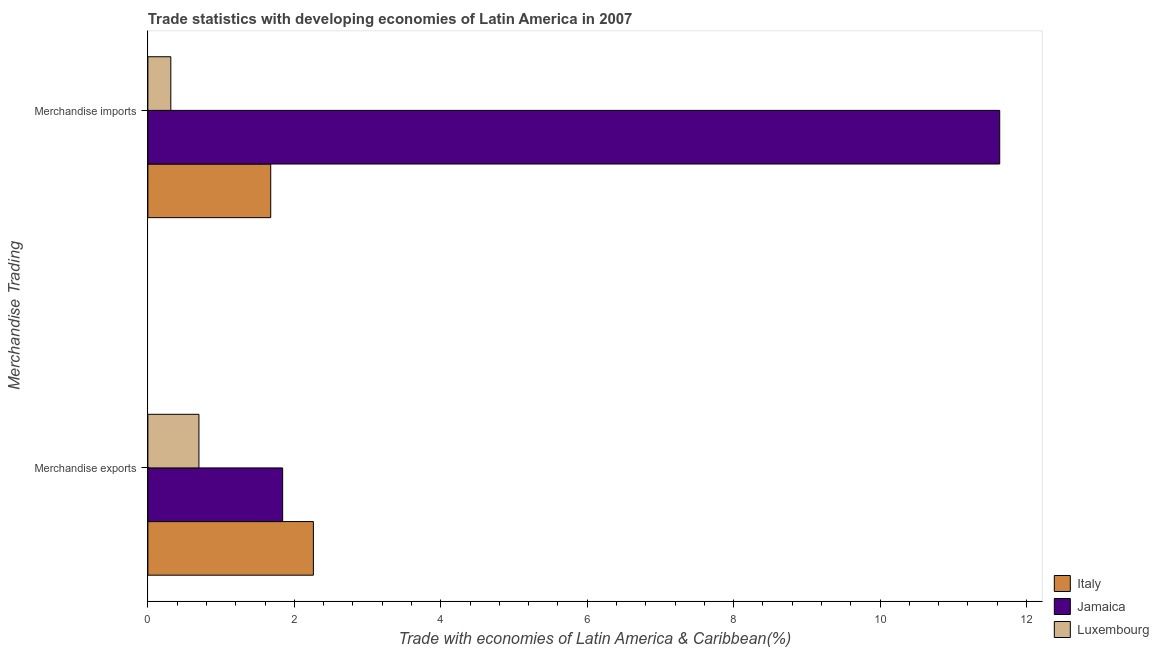How many groups of bars are there?
Make the answer very short. 2. Are the number of bars per tick equal to the number of legend labels?
Your answer should be compact. Yes. How many bars are there on the 2nd tick from the top?
Make the answer very short. 3. How many bars are there on the 2nd tick from the bottom?
Your answer should be very brief. 3. What is the merchandise exports in Italy?
Ensure brevity in your answer.  2.26. Across all countries, what is the maximum merchandise imports?
Your answer should be very brief. 11.63. Across all countries, what is the minimum merchandise exports?
Provide a succinct answer. 0.7. In which country was the merchandise imports maximum?
Make the answer very short. Jamaica. In which country was the merchandise exports minimum?
Your answer should be very brief. Luxembourg. What is the total merchandise exports in the graph?
Keep it short and to the point. 4.8. What is the difference between the merchandise imports in Italy and that in Jamaica?
Your response must be concise. -9.96. What is the difference between the merchandise imports in Jamaica and the merchandise exports in Italy?
Offer a terse response. 9.37. What is the average merchandise imports per country?
Your answer should be compact. 4.54. What is the difference between the merchandise exports and merchandise imports in Luxembourg?
Offer a very short reply. 0.38. What is the ratio of the merchandise imports in Luxembourg to that in Jamaica?
Your answer should be compact. 0.03. What does the 3rd bar from the top in Merchandise exports represents?
Give a very brief answer. Italy. What does the 3rd bar from the bottom in Merchandise exports represents?
Provide a short and direct response. Luxembourg. How many bars are there?
Keep it short and to the point. 6. Are all the bars in the graph horizontal?
Your response must be concise. Yes. How many countries are there in the graph?
Ensure brevity in your answer.  3. Where does the legend appear in the graph?
Provide a succinct answer. Bottom right. What is the title of the graph?
Provide a succinct answer. Trade statistics with developing economies of Latin America in 2007. Does "Euro area" appear as one of the legend labels in the graph?
Your answer should be compact. No. What is the label or title of the X-axis?
Your answer should be compact. Trade with economies of Latin America & Caribbean(%). What is the label or title of the Y-axis?
Your response must be concise. Merchandise Trading. What is the Trade with economies of Latin America & Caribbean(%) in Italy in Merchandise exports?
Make the answer very short. 2.26. What is the Trade with economies of Latin America & Caribbean(%) of Jamaica in Merchandise exports?
Offer a terse response. 1.84. What is the Trade with economies of Latin America & Caribbean(%) of Luxembourg in Merchandise exports?
Provide a succinct answer. 0.7. What is the Trade with economies of Latin America & Caribbean(%) in Italy in Merchandise imports?
Provide a succinct answer. 1.68. What is the Trade with economies of Latin America & Caribbean(%) of Jamaica in Merchandise imports?
Offer a terse response. 11.63. What is the Trade with economies of Latin America & Caribbean(%) in Luxembourg in Merchandise imports?
Your answer should be very brief. 0.31. Across all Merchandise Trading, what is the maximum Trade with economies of Latin America & Caribbean(%) in Italy?
Provide a succinct answer. 2.26. Across all Merchandise Trading, what is the maximum Trade with economies of Latin America & Caribbean(%) in Jamaica?
Your answer should be very brief. 11.63. Across all Merchandise Trading, what is the maximum Trade with economies of Latin America & Caribbean(%) in Luxembourg?
Provide a short and direct response. 0.7. Across all Merchandise Trading, what is the minimum Trade with economies of Latin America & Caribbean(%) in Italy?
Offer a terse response. 1.68. Across all Merchandise Trading, what is the minimum Trade with economies of Latin America & Caribbean(%) of Jamaica?
Your answer should be very brief. 1.84. Across all Merchandise Trading, what is the minimum Trade with economies of Latin America & Caribbean(%) of Luxembourg?
Your answer should be compact. 0.31. What is the total Trade with economies of Latin America & Caribbean(%) in Italy in the graph?
Your answer should be compact. 3.94. What is the total Trade with economies of Latin America & Caribbean(%) in Jamaica in the graph?
Your response must be concise. 13.47. What is the total Trade with economies of Latin America & Caribbean(%) of Luxembourg in the graph?
Ensure brevity in your answer.  1.01. What is the difference between the Trade with economies of Latin America & Caribbean(%) of Italy in Merchandise exports and that in Merchandise imports?
Your answer should be very brief. 0.58. What is the difference between the Trade with economies of Latin America & Caribbean(%) of Jamaica in Merchandise exports and that in Merchandise imports?
Your answer should be very brief. -9.79. What is the difference between the Trade with economies of Latin America & Caribbean(%) of Luxembourg in Merchandise exports and that in Merchandise imports?
Your response must be concise. 0.38. What is the difference between the Trade with economies of Latin America & Caribbean(%) in Italy in Merchandise exports and the Trade with economies of Latin America & Caribbean(%) in Jamaica in Merchandise imports?
Offer a terse response. -9.37. What is the difference between the Trade with economies of Latin America & Caribbean(%) in Italy in Merchandise exports and the Trade with economies of Latin America & Caribbean(%) in Luxembourg in Merchandise imports?
Keep it short and to the point. 1.95. What is the difference between the Trade with economies of Latin America & Caribbean(%) in Jamaica in Merchandise exports and the Trade with economies of Latin America & Caribbean(%) in Luxembourg in Merchandise imports?
Your response must be concise. 1.53. What is the average Trade with economies of Latin America & Caribbean(%) of Italy per Merchandise Trading?
Your answer should be very brief. 1.97. What is the average Trade with economies of Latin America & Caribbean(%) of Jamaica per Merchandise Trading?
Your answer should be compact. 6.74. What is the average Trade with economies of Latin America & Caribbean(%) of Luxembourg per Merchandise Trading?
Ensure brevity in your answer.  0.51. What is the difference between the Trade with economies of Latin America & Caribbean(%) in Italy and Trade with economies of Latin America & Caribbean(%) in Jamaica in Merchandise exports?
Ensure brevity in your answer.  0.42. What is the difference between the Trade with economies of Latin America & Caribbean(%) of Italy and Trade with economies of Latin America & Caribbean(%) of Luxembourg in Merchandise exports?
Give a very brief answer. 1.56. What is the difference between the Trade with economies of Latin America & Caribbean(%) in Jamaica and Trade with economies of Latin America & Caribbean(%) in Luxembourg in Merchandise exports?
Give a very brief answer. 1.14. What is the difference between the Trade with economies of Latin America & Caribbean(%) in Italy and Trade with economies of Latin America & Caribbean(%) in Jamaica in Merchandise imports?
Make the answer very short. -9.96. What is the difference between the Trade with economies of Latin America & Caribbean(%) in Italy and Trade with economies of Latin America & Caribbean(%) in Luxembourg in Merchandise imports?
Keep it short and to the point. 1.36. What is the difference between the Trade with economies of Latin America & Caribbean(%) in Jamaica and Trade with economies of Latin America & Caribbean(%) in Luxembourg in Merchandise imports?
Your response must be concise. 11.32. What is the ratio of the Trade with economies of Latin America & Caribbean(%) in Italy in Merchandise exports to that in Merchandise imports?
Your answer should be very brief. 1.35. What is the ratio of the Trade with economies of Latin America & Caribbean(%) in Jamaica in Merchandise exports to that in Merchandise imports?
Make the answer very short. 0.16. What is the ratio of the Trade with economies of Latin America & Caribbean(%) of Luxembourg in Merchandise exports to that in Merchandise imports?
Your response must be concise. 2.23. What is the difference between the highest and the second highest Trade with economies of Latin America & Caribbean(%) in Italy?
Make the answer very short. 0.58. What is the difference between the highest and the second highest Trade with economies of Latin America & Caribbean(%) of Jamaica?
Your answer should be compact. 9.79. What is the difference between the highest and the second highest Trade with economies of Latin America & Caribbean(%) in Luxembourg?
Offer a terse response. 0.38. What is the difference between the highest and the lowest Trade with economies of Latin America & Caribbean(%) in Italy?
Your response must be concise. 0.58. What is the difference between the highest and the lowest Trade with economies of Latin America & Caribbean(%) in Jamaica?
Offer a very short reply. 9.79. What is the difference between the highest and the lowest Trade with economies of Latin America & Caribbean(%) in Luxembourg?
Give a very brief answer. 0.38. 